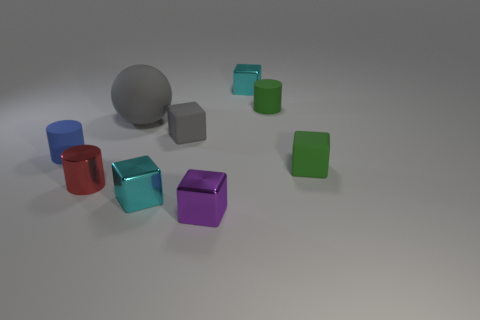Does the rubber thing that is to the left of the big gray sphere have the same shape as the green object that is behind the gray rubber cube?
Provide a succinct answer. Yes. What material is the gray cube that is the same size as the red metal cylinder?
Make the answer very short. Rubber. What number of other things are the same material as the large thing?
Your answer should be compact. 4. There is a cyan metallic thing that is left of the cyan cube behind the tiny red shiny cylinder; what shape is it?
Your answer should be compact. Cube. How many things are either green cylinders or tiny red shiny objects on the right side of the small blue object?
Your response must be concise. 2. What number of other objects are the same color as the ball?
Your answer should be very brief. 1. How many gray objects are spheres or metal cylinders?
Make the answer very short. 1. There is a rubber cube that is to the left of the tiny green matte object that is in front of the tiny gray thing; are there any cyan metal blocks right of it?
Give a very brief answer. Yes. Is there anything else that is the same size as the sphere?
Your answer should be very brief. No. Is the large thing the same color as the metallic cylinder?
Provide a short and direct response. No. 